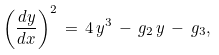Convert formula to latex. <formula><loc_0><loc_0><loc_500><loc_500>\left ( \frac { d y } { d x } \right ) ^ { 2 } \, = \, 4 \, y ^ { 3 } \, - \, g _ { 2 } \, y \, - \, g _ { 3 } ,</formula> 